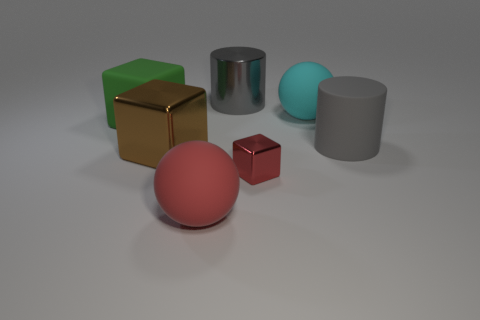What number of big rubber things have the same color as the tiny object?
Your answer should be very brief. 1. There is a large cylinder right of the red metal block; is its color the same as the large shiny thing that is behind the large rubber cylinder?
Offer a terse response. Yes. What number of objects are to the right of the large green matte object and left of the big gray rubber cylinder?
Offer a terse response. 5. What material is the cyan object?
Provide a short and direct response. Rubber. Is there anything else of the same color as the large metallic cube?
Offer a terse response. No. Does the large green block have the same material as the tiny red object?
Ensure brevity in your answer.  No. How many large matte spheres are in front of the big shiny thing that is in front of the rubber sphere that is right of the tiny thing?
Your answer should be very brief. 1. What number of metallic cylinders are there?
Provide a succinct answer. 1. Are there fewer green matte blocks in front of the large green thing than big brown objects on the left side of the large gray metallic cylinder?
Offer a terse response. Yes. Is the number of gray metallic objects that are on the left side of the green matte block less than the number of small rubber blocks?
Ensure brevity in your answer.  No. 